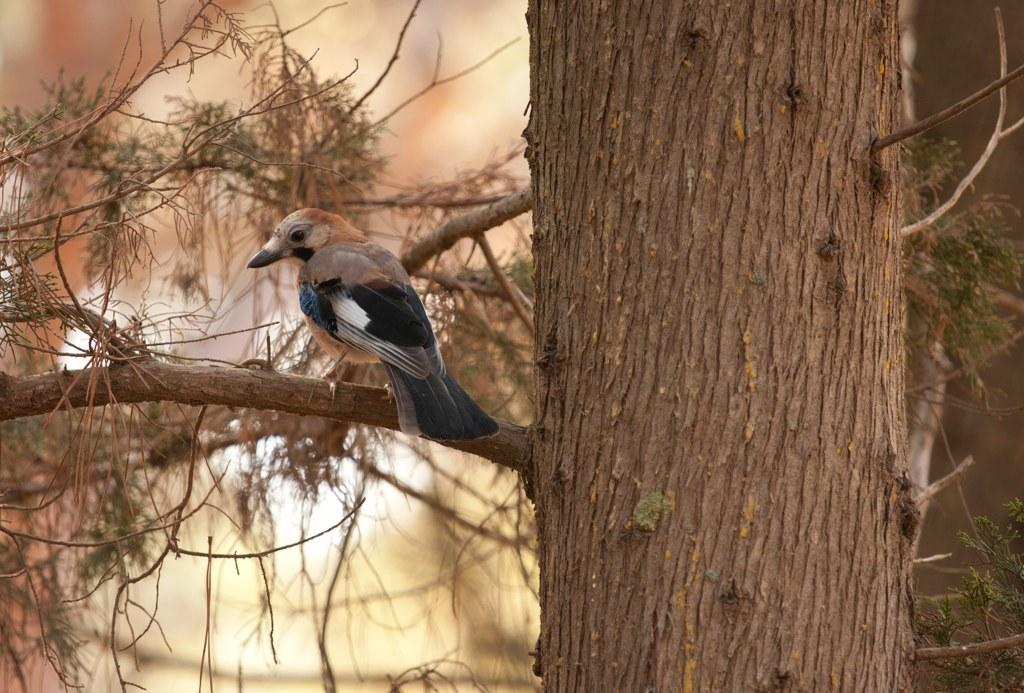What type of animal can be seen in the image? There is a bird in the image. Where is the bird located? The bird is on the branch of a tree. Can you describe the background of the image? The background of the image is blurred. What type of shade does the donkey provide in the image? There is no donkey present in the image, so it cannot provide any shade. 